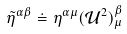Convert formula to latex. <formula><loc_0><loc_0><loc_500><loc_500>\tilde { \eta } ^ { \alpha \beta } \doteq \eta ^ { \alpha \mu } ( \mathcal { U } ^ { 2 } ) ^ { \beta } _ { \mu }</formula> 